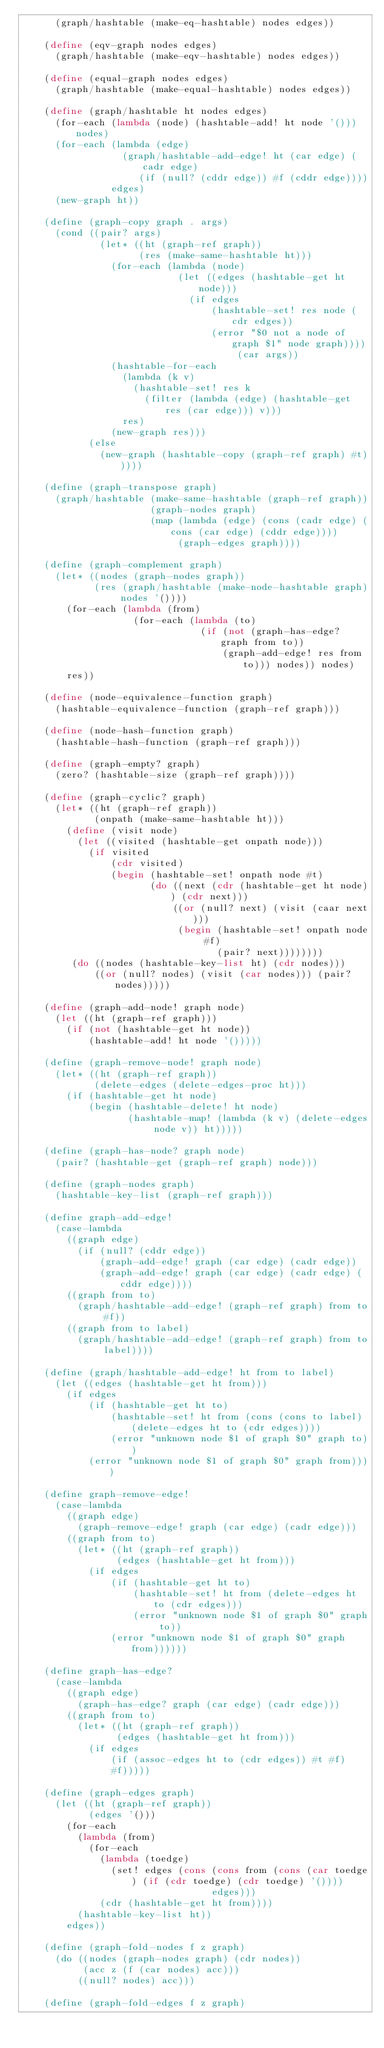Convert code to text. <code><loc_0><loc_0><loc_500><loc_500><_Scheme_>      (graph/hashtable (make-eq-hashtable) nodes edges))

    (define (eqv-graph nodes edges)
      (graph/hashtable (make-eqv-hashtable) nodes edges))

    (define (equal-graph nodes edges)
      (graph/hashtable (make-equal-hashtable) nodes edges))

    (define (graph/hashtable ht nodes edges)
      (for-each (lambda (node) (hashtable-add! ht node '())) nodes)
      (for-each (lambda (edge)
                  (graph/hashtable-add-edge! ht (car edge) (cadr edge)
                     (if (null? (cddr edge)) #f (cddr edge))))
                edges)
      (new-graph ht))

    (define (graph-copy graph . args)
      (cond ((pair? args)
              (let* ((ht (graph-ref graph))
                     (res (make-same-hashtable ht)))
                (for-each (lambda (node)
                            (let ((edges (hashtable-get ht node)))
                              (if edges
                                  (hashtable-set! res node (cdr edges))
                                  (error "$0 not a node of graph $1" node graph)))) (car args))
                (hashtable-for-each
                  (lambda (k v)
                    (hashtable-set! res k
                      (filter (lambda (edge) (hashtable-get res (car edge))) v)))
                  res)
                (new-graph res)))
            (else
              (new-graph (hashtable-copy (graph-ref graph) #t)))))

    (define (graph-transpose graph)
      (graph/hashtable (make-same-hashtable (graph-ref graph))
                       (graph-nodes graph)
                       (map (lambda (edge) (cons (cadr edge) (cons (car edge) (cddr edge))))
                            (graph-edges graph))))

    (define (graph-complement graph)
      (let* ((nodes (graph-nodes graph))
             (res (graph/hashtable (make-node-hashtable graph) nodes '())))
        (for-each (lambda (from)
                    (for-each (lambda (to)
                                (if (not (graph-has-edge? graph from to))
                                    (graph-add-edge! res from to))) nodes)) nodes)
        res))

    (define (node-equivalence-function graph)
      (hashtable-equivalence-function (graph-ref graph)))

    (define (node-hash-function graph)
      (hashtable-hash-function (graph-ref graph)))

    (define (graph-empty? graph)
      (zero? (hashtable-size (graph-ref graph))))

    (define (graph-cyclic? graph)
      (let* ((ht (graph-ref graph))
             (onpath (make-same-hashtable ht)))
        (define (visit node)
          (let ((visited (hashtable-get onpath node)))
            (if visited
                (cdr visited)
                (begin (hashtable-set! onpath node #t)
                       (do ((next (cdr (hashtable-get ht node)) (cdr next)))
                           ((or (null? next) (visit (caar next)))
                            (begin (hashtable-set! onpath node #f)
                                   (pair? next))))))))
         (do ((nodes (hashtable-key-list ht) (cdr nodes)))
             ((or (null? nodes) (visit (car nodes))) (pair? nodes)))))

    (define (graph-add-node! graph node)
      (let ((ht (graph-ref graph)))
        (if (not (hashtable-get ht node))
            (hashtable-add! ht node '()))))

    (define (graph-remove-node! graph node)
      (let* ((ht (graph-ref graph))
             (delete-edges (delete-edges-proc ht)))
        (if (hashtable-get ht node)
            (begin (hashtable-delete! ht node)
                   (hashtable-map! (lambda (k v) (delete-edges node v)) ht)))))

    (define (graph-has-node? graph node)
      (pair? (hashtable-get (graph-ref graph) node)))

    (define (graph-nodes graph)
      (hashtable-key-list (graph-ref graph)))

    (define graph-add-edge!
      (case-lambda
        ((graph edge)
          (if (null? (cddr edge))
              (graph-add-edge! graph (car edge) (cadr edge))
              (graph-add-edge! graph (car edge) (cadr edge) (cddr edge))))
        ((graph from to)
          (graph/hashtable-add-edge! (graph-ref graph) from to #f))
        ((graph from to label)
          (graph/hashtable-add-edge! (graph-ref graph) from to label))))

    (define (graph/hashtable-add-edge! ht from to label)
      (let ((edges (hashtable-get ht from)))
        (if edges
            (if (hashtable-get ht to)
                (hashtable-set! ht from (cons (cons to label) (delete-edges ht to (cdr edges))))
                (error "unknown node $1 of graph $0" graph to))
            (error "unknown node $1 of graph $0" graph from))))

    (define graph-remove-edge!
      (case-lambda
        ((graph edge)
          (graph-remove-edge! graph (car edge) (cadr edge)))
        ((graph from to)
          (let* ((ht (graph-ref graph))
                 (edges (hashtable-get ht from)))
            (if edges
                (if (hashtable-get ht to)
                    (hashtable-set! ht from (delete-edges ht to (cdr edges)))
                    (error "unknown node $1 of graph $0" graph to))
                (error "unknown node $1 of graph $0" graph from))))))

    (define graph-has-edge?
      (case-lambda
        ((graph edge)
          (graph-has-edge? graph (car edge) (cadr edge)))
        ((graph from to)
          (let* ((ht (graph-ref graph))
                 (edges (hashtable-get ht from)))
            (if edges
                (if (assoc-edges ht to (cdr edges)) #t #f)
                #f)))))

    (define (graph-edges graph)
      (let ((ht (graph-ref graph))
            (edges '()))
        (for-each
          (lambda (from)
            (for-each
              (lambda (toedge)
                (set! edges (cons (cons from (cons (car toedge) (if (cdr toedge) (cdr toedge) '())))
                                  edges)))
              (cdr (hashtable-get ht from))))
          (hashtable-key-list ht))
        edges))

    (define (graph-fold-nodes f z graph)
      (do ((nodes (graph-nodes graph) (cdr nodes))
           (acc z (f (car nodes) acc)))
          ((null? nodes) acc)))

    (define (graph-fold-edges f z graph)</code> 